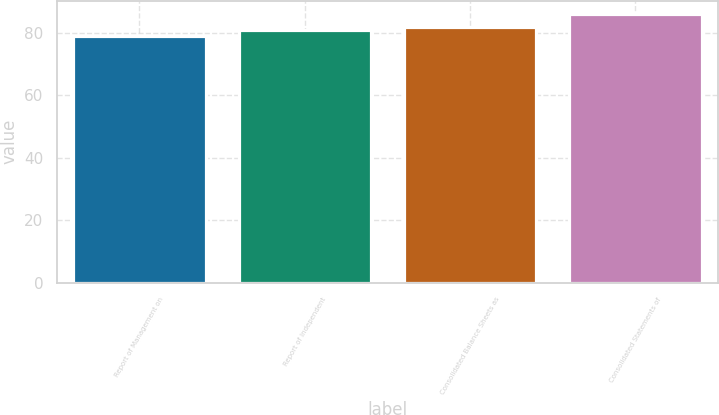<chart> <loc_0><loc_0><loc_500><loc_500><bar_chart><fcel>Report of Management on<fcel>Report of Independent<fcel>Consolidated Balance Sheets as<fcel>Consolidated Statements of<nl><fcel>79<fcel>81<fcel>82<fcel>86<nl></chart> 